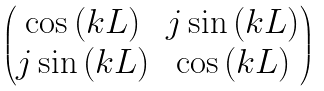<formula> <loc_0><loc_0><loc_500><loc_500>\begin{pmatrix} \cos { ( k L ) } & j \sin { ( k L ) } \\ j \sin { ( k L ) } & \cos { ( k L ) } \end{pmatrix}</formula> 